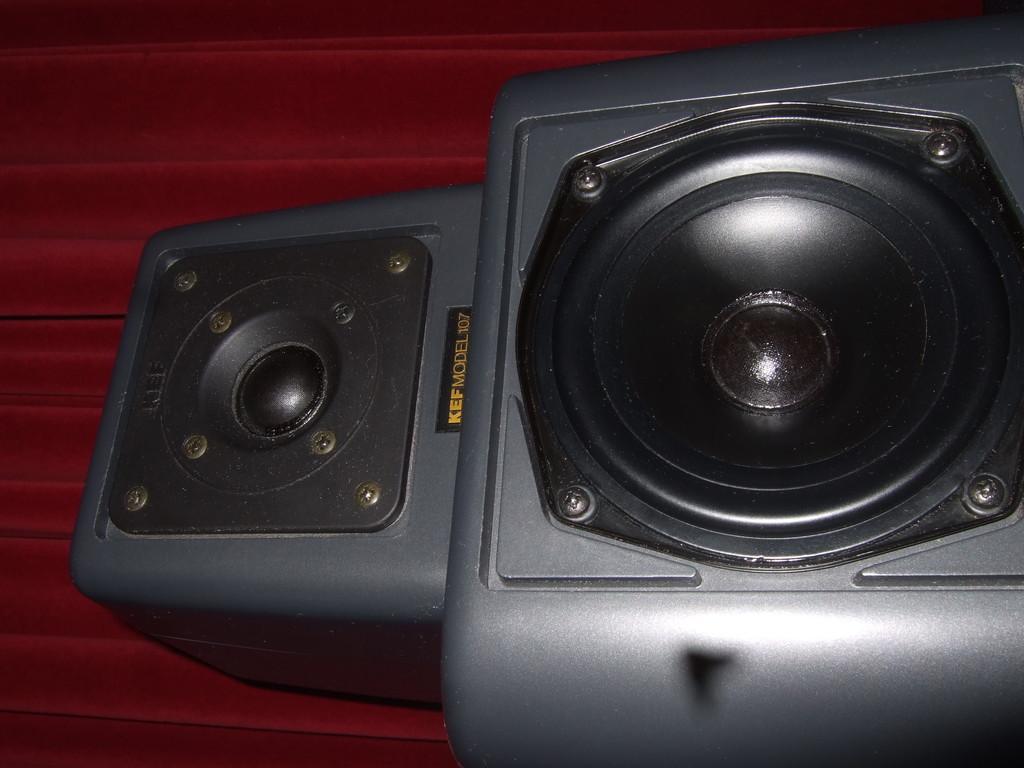In one or two sentences, can you explain what this image depicts? In the picture we can see speakers on a platform. 